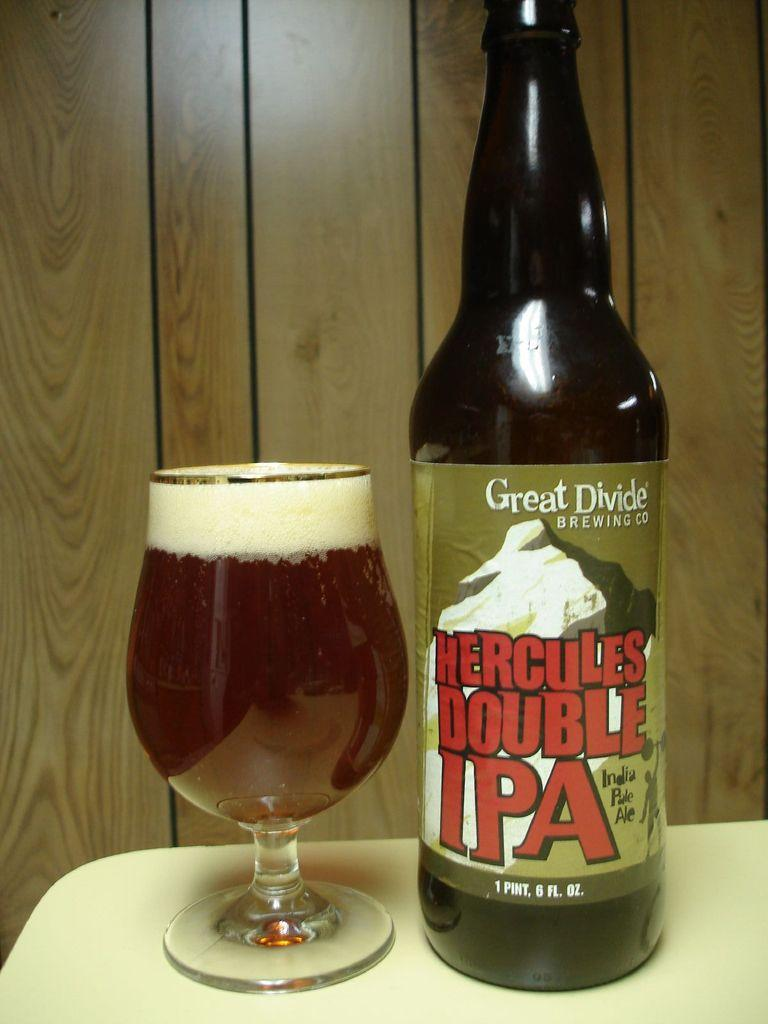Provide a one-sentence caption for the provided image. A bottle of Hercules Double IPA has been poured into a glass. 